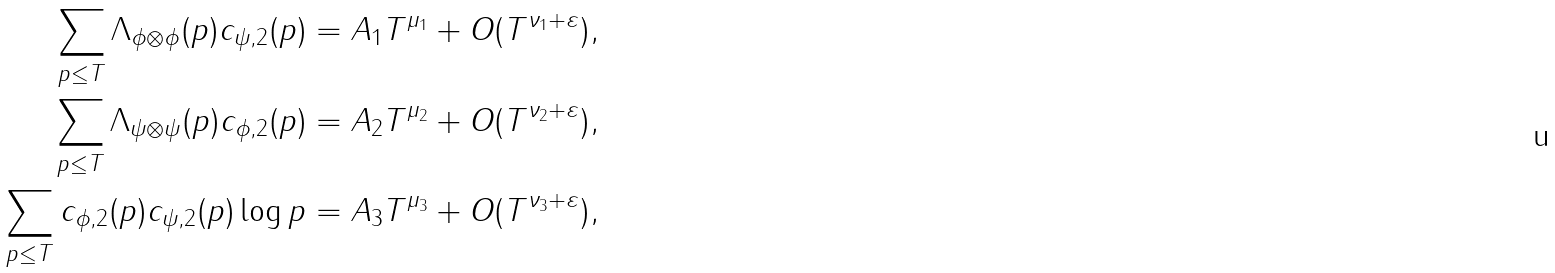<formula> <loc_0><loc_0><loc_500><loc_500>\sum _ { p \leq T } \Lambda _ { \phi \otimes \phi } ( p ) c _ { \psi , 2 } ( p ) = A _ { 1 } T ^ { \mu _ { 1 } } + O ( T ^ { \nu _ { 1 } + \varepsilon } ) , \\ \sum _ { p \leq T } \Lambda _ { \psi \otimes \psi } ( p ) c _ { \phi , 2 } ( p ) = A _ { 2 } T ^ { \mu _ { 2 } } + O ( T ^ { \nu _ { 2 } + \varepsilon } ) , \\ \sum _ { p \leq T } c _ { \phi , 2 } ( p ) c _ { \psi , 2 } ( p ) \log p = A _ { 3 } T ^ { \mu _ { 3 } } + O ( T ^ { \nu _ { 3 } + \varepsilon } ) ,</formula> 